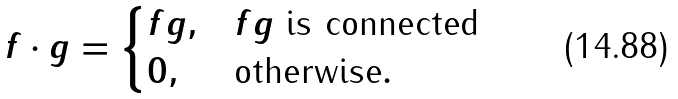Convert formula to latex. <formula><loc_0><loc_0><loc_500><loc_500>f \cdot g = \begin{cases} f g , & \text {$fg$ is connected} \\ 0 , & \text {otherwise} . \end{cases}</formula> 